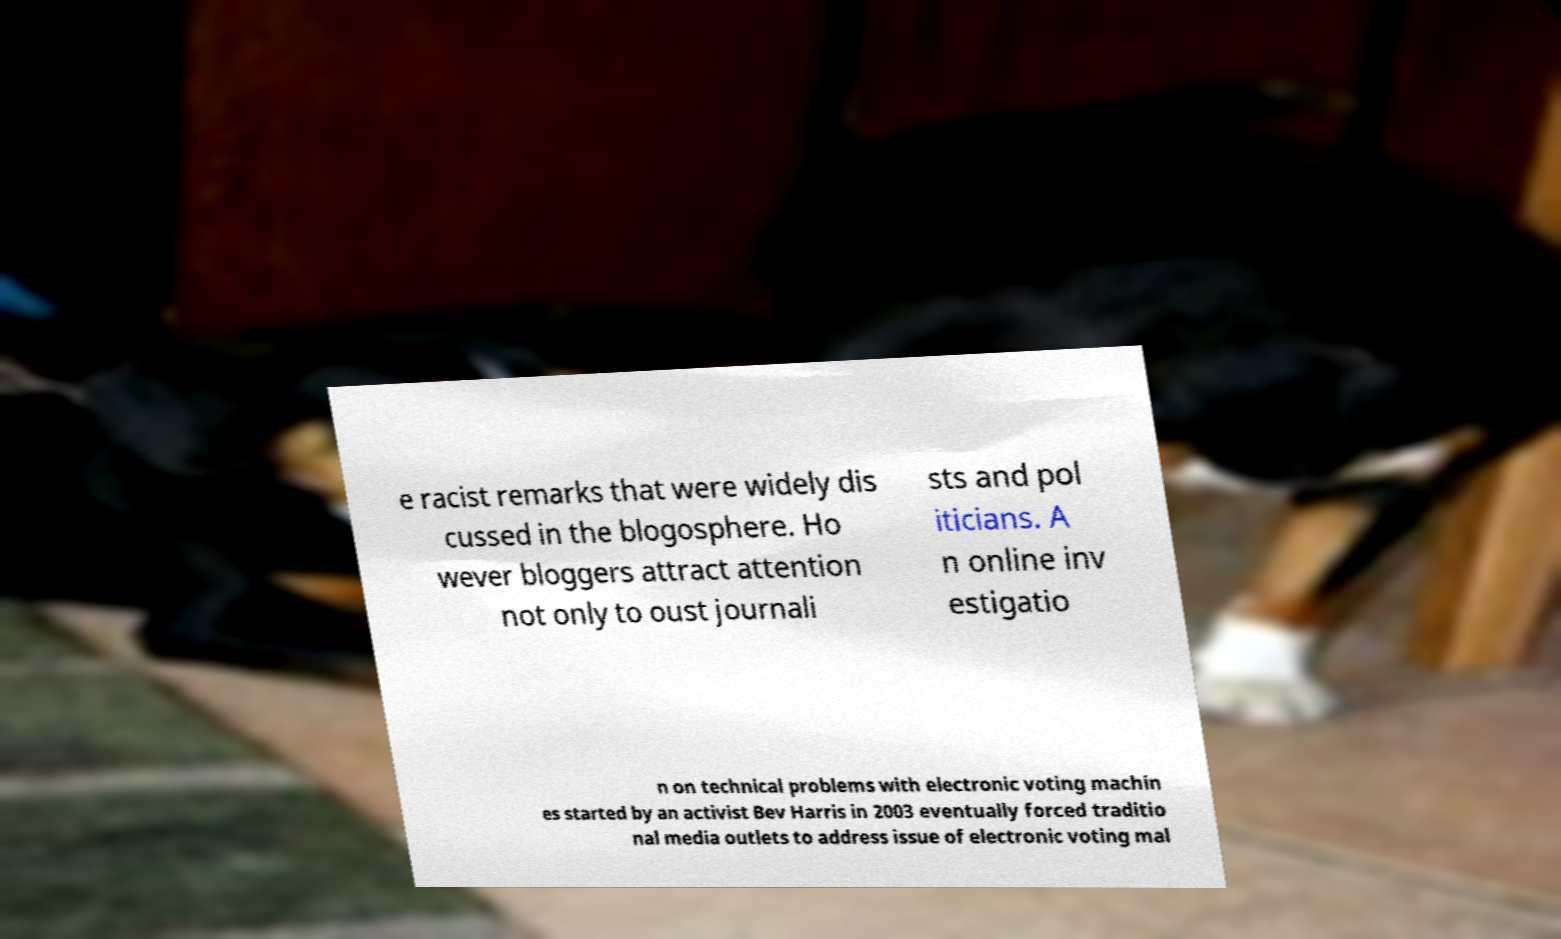There's text embedded in this image that I need extracted. Can you transcribe it verbatim? e racist remarks that were widely dis cussed in the blogosphere. Ho wever bloggers attract attention not only to oust journali sts and pol iticians. A n online inv estigatio n on technical problems with electronic voting machin es started by an activist Bev Harris in 2003 eventually forced traditio nal media outlets to address issue of electronic voting mal 